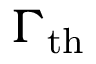<formula> <loc_0><loc_0><loc_500><loc_500>\Gamma _ { t h }</formula> 